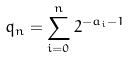<formula> <loc_0><loc_0><loc_500><loc_500>q _ { n } = \sum _ { i = 0 } ^ { n } 2 ^ { - a _ { i } - 1 }</formula> 